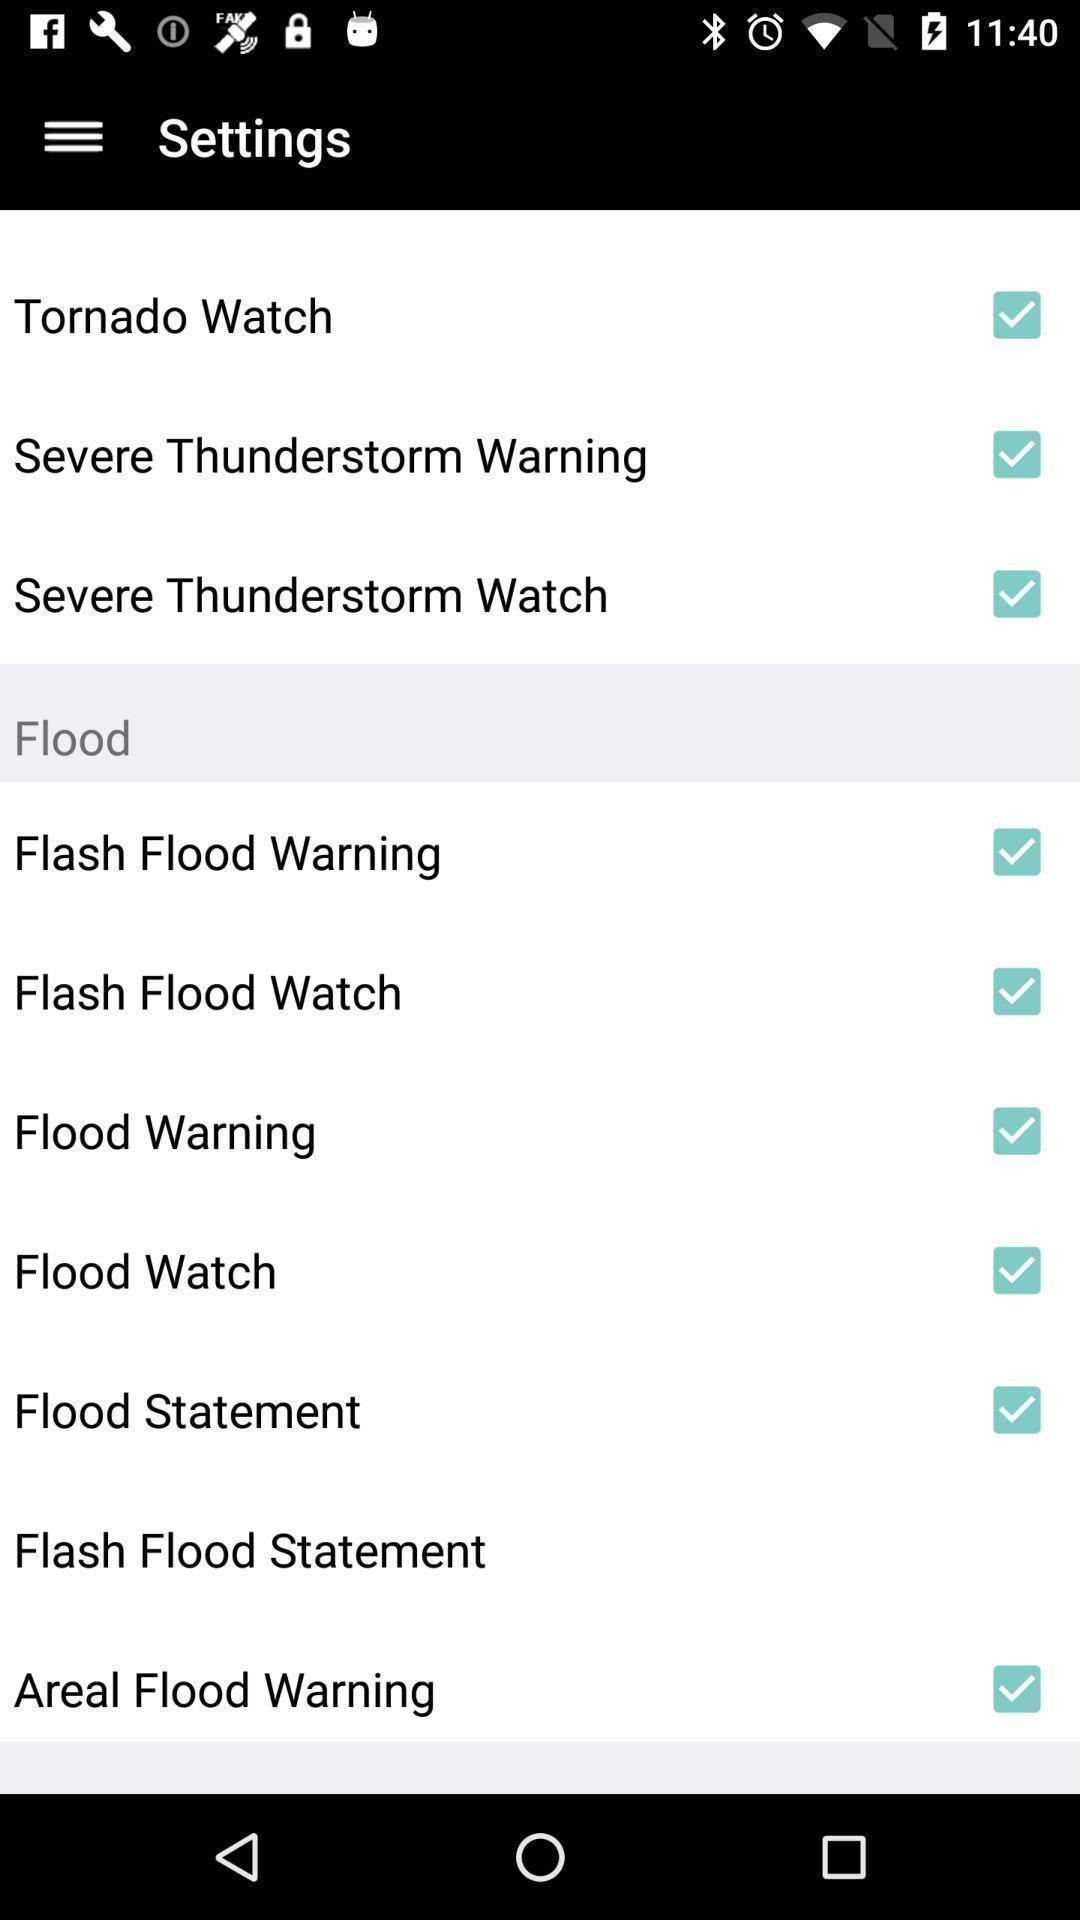Describe the key features of this screenshot. Variety of options under settings. 